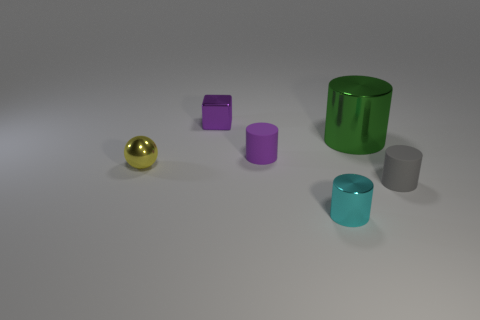There is a object that is both in front of the purple matte thing and left of the cyan shiny object; what is its material?
Your answer should be very brief. Metal. Are there any other cylinders of the same size as the gray cylinder?
Offer a very short reply. Yes. What material is the yellow ball that is the same size as the purple rubber thing?
Keep it short and to the point. Metal. There is a cyan thing; how many tiny objects are behind it?
Your answer should be very brief. 4. Is the shape of the rubber thing that is in front of the yellow sphere the same as  the small cyan shiny object?
Offer a terse response. Yes. Is there a tiny cyan thing that has the same shape as the small yellow object?
Make the answer very short. No. There is a tiny cylinder that is the same color as the tiny metallic cube; what material is it?
Your response must be concise. Rubber. The metal object that is in front of the small yellow object that is on the left side of the shiny block is what shape?
Keep it short and to the point. Cylinder. How many purple objects are made of the same material as the small block?
Your answer should be compact. 0. There is a large object that is made of the same material as the block; what color is it?
Keep it short and to the point. Green. 